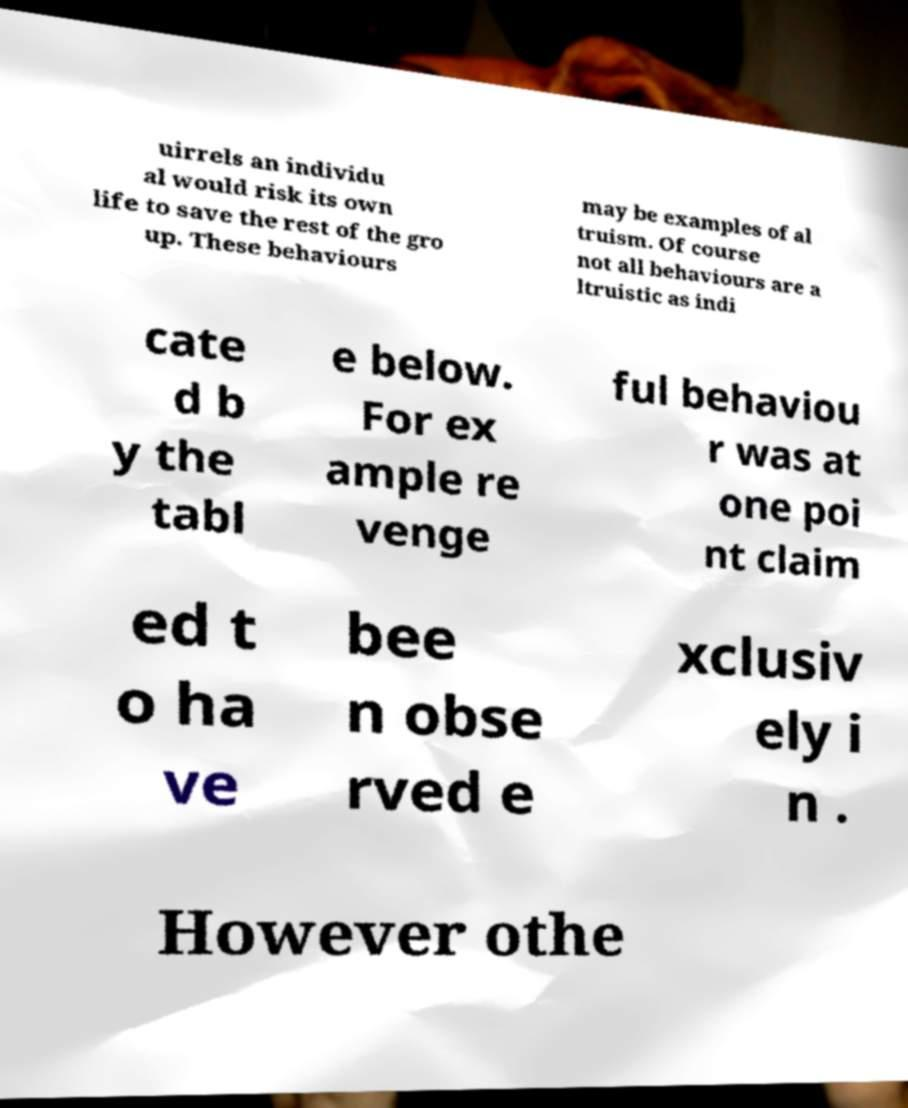What messages or text are displayed in this image? I need them in a readable, typed format. uirrels an individu al would risk its own life to save the rest of the gro up. These behaviours may be examples of al truism. Of course not all behaviours are a ltruistic as indi cate d b y the tabl e below. For ex ample re venge ful behaviou r was at one poi nt claim ed t o ha ve bee n obse rved e xclusiv ely i n . However othe 